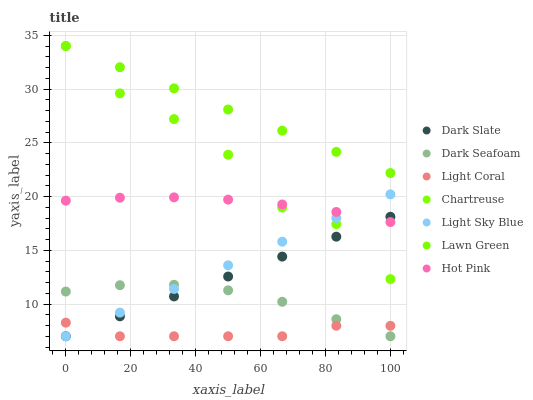Does Light Coral have the minimum area under the curve?
Answer yes or no. Yes. Does Lawn Green have the maximum area under the curve?
Answer yes or no. Yes. Does Hot Pink have the minimum area under the curve?
Answer yes or no. No. Does Hot Pink have the maximum area under the curve?
Answer yes or no. No. Is Dark Slate the smoothest?
Answer yes or no. Yes. Is Chartreuse the roughest?
Answer yes or no. Yes. Is Hot Pink the smoothest?
Answer yes or no. No. Is Hot Pink the roughest?
Answer yes or no. No. Does Light Coral have the lowest value?
Answer yes or no. Yes. Does Hot Pink have the lowest value?
Answer yes or no. No. Does Chartreuse have the highest value?
Answer yes or no. Yes. Does Hot Pink have the highest value?
Answer yes or no. No. Is Light Coral less than Hot Pink?
Answer yes or no. Yes. Is Lawn Green greater than Dark Slate?
Answer yes or no. Yes. Does Dark Seafoam intersect Dark Slate?
Answer yes or no. Yes. Is Dark Seafoam less than Dark Slate?
Answer yes or no. No. Is Dark Seafoam greater than Dark Slate?
Answer yes or no. No. Does Light Coral intersect Hot Pink?
Answer yes or no. No. 